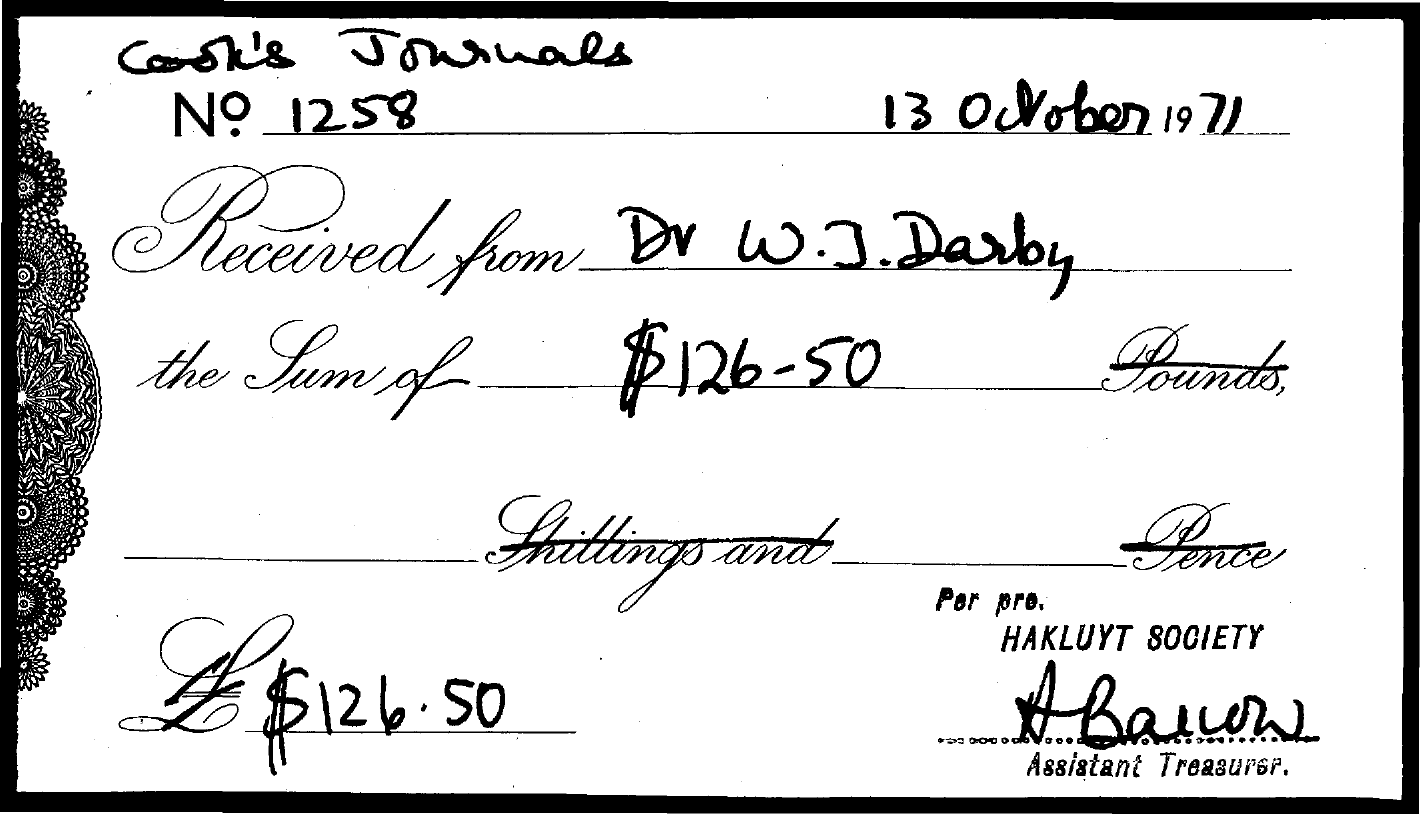Indicate a few pertinent items in this graphic. The cook's journal number mentioned in the given document is 1258. The sum amount mentioned in the given document is $126 - $50. The date mentioned in the document is 13 October 1971. 